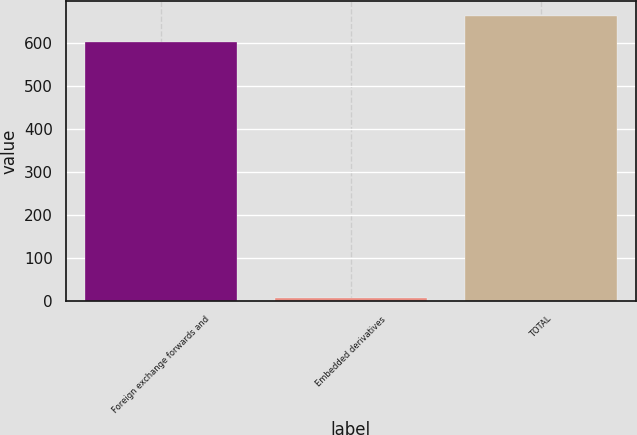Convert chart. <chart><loc_0><loc_0><loc_500><loc_500><bar_chart><fcel>Foreign exchange forwards and<fcel>Embedded derivatives<fcel>TOTAL<nl><fcel>603<fcel>7<fcel>664<nl></chart> 